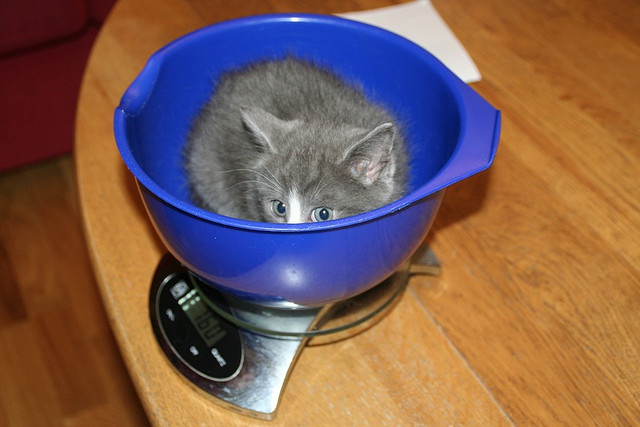Describe the objects in this image and their specific colors. I can see dining table in red, maroon, tan, gray, and darkblue tones and bowl in maroon, gray, darkblue, blue, and darkgray tones in this image. 